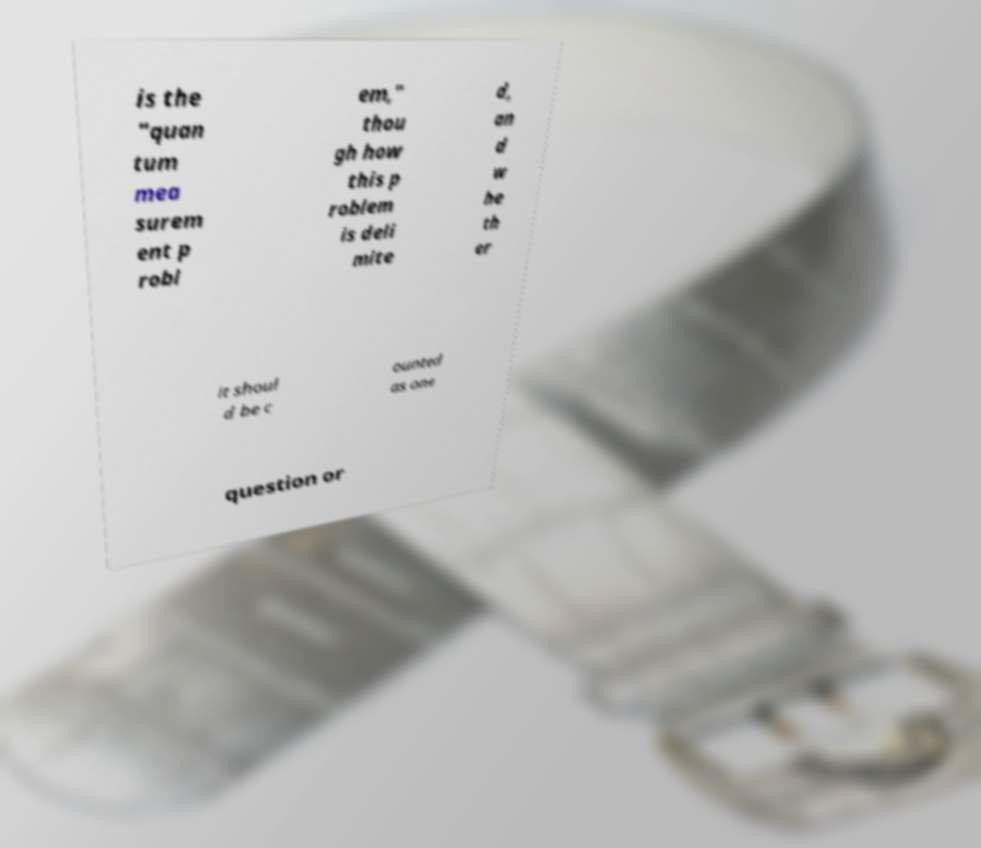Please read and relay the text visible in this image. What does it say? is the "quan tum mea surem ent p robl em," thou gh how this p roblem is deli mite d, an d w he th er it shoul d be c ounted as one question or 